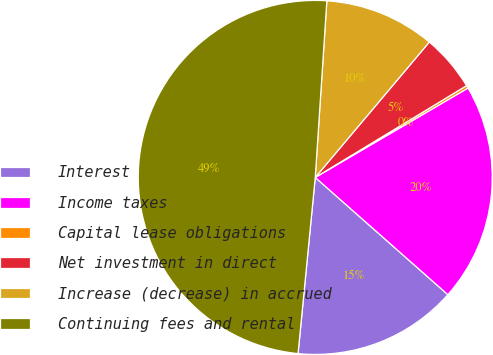Convert chart. <chart><loc_0><loc_0><loc_500><loc_500><pie_chart><fcel>Interest<fcel>Income taxes<fcel>Capital lease obligations<fcel>Net investment in direct<fcel>Increase (decrease) in accrued<fcel>Continuing fees and rental<nl><fcel>15.03%<fcel>19.95%<fcel>0.25%<fcel>5.18%<fcel>10.1%<fcel>49.5%<nl></chart> 